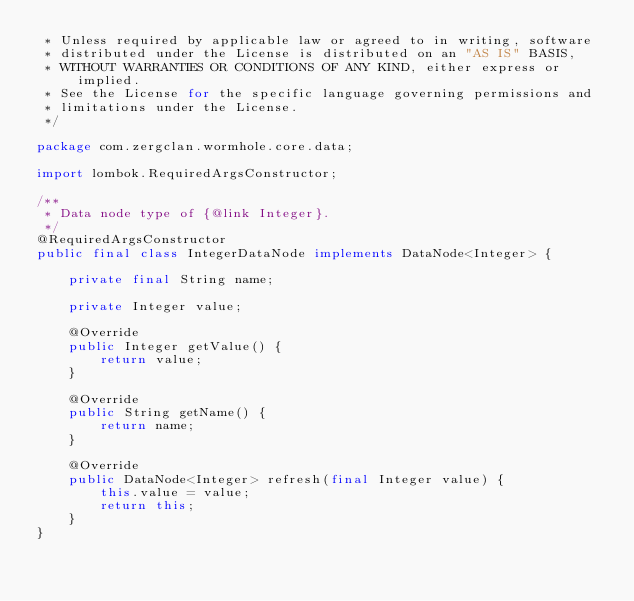<code> <loc_0><loc_0><loc_500><loc_500><_Java_> * Unless required by applicable law or agreed to in writing, software
 * distributed under the License is distributed on an "AS IS" BASIS,
 * WITHOUT WARRANTIES OR CONDITIONS OF ANY KIND, either express or implied.
 * See the License for the specific language governing permissions and
 * limitations under the License.
 */

package com.zergclan.wormhole.core.data;

import lombok.RequiredArgsConstructor;

/**
 * Data node type of {@link Integer}.
 */
@RequiredArgsConstructor
public final class IntegerDataNode implements DataNode<Integer> {
    
    private final String name;
    
    private Integer value;
    
    @Override
    public Integer getValue() {
        return value;
    }
    
    @Override
    public String getName() {
        return name;
    }
    
    @Override
    public DataNode<Integer> refresh(final Integer value) {
        this.value = value;
        return this;
    }
}
</code> 